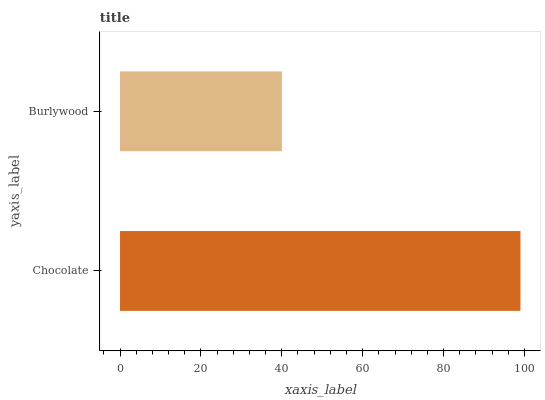Is Burlywood the minimum?
Answer yes or no. Yes. Is Chocolate the maximum?
Answer yes or no. Yes. Is Burlywood the maximum?
Answer yes or no. No. Is Chocolate greater than Burlywood?
Answer yes or no. Yes. Is Burlywood less than Chocolate?
Answer yes or no. Yes. Is Burlywood greater than Chocolate?
Answer yes or no. No. Is Chocolate less than Burlywood?
Answer yes or no. No. Is Chocolate the high median?
Answer yes or no. Yes. Is Burlywood the low median?
Answer yes or no. Yes. Is Burlywood the high median?
Answer yes or no. No. Is Chocolate the low median?
Answer yes or no. No. 